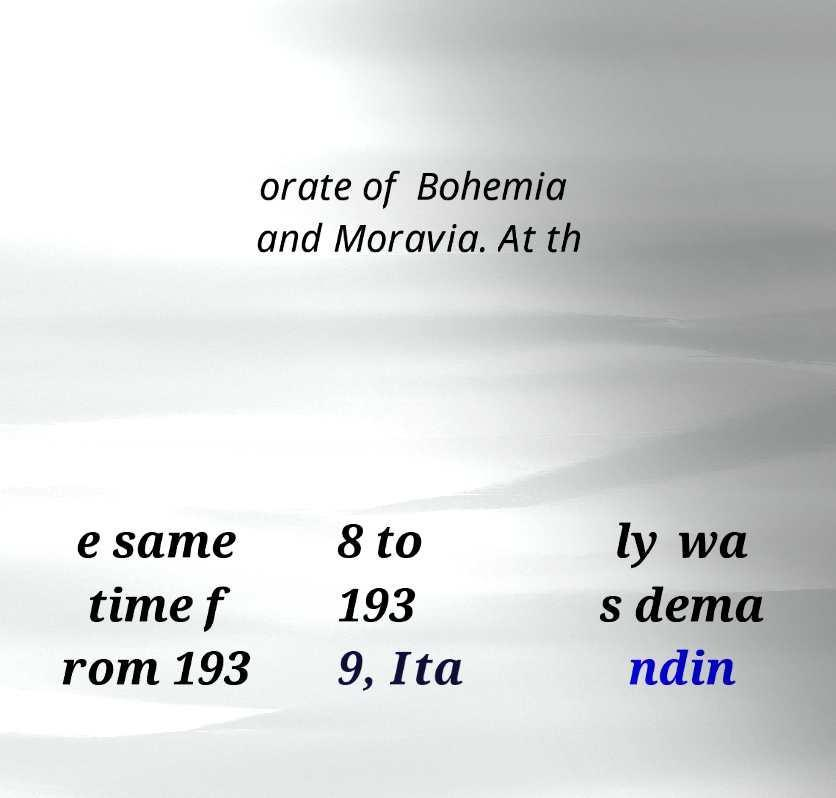Can you accurately transcribe the text from the provided image for me? orate of Bohemia and Moravia. At th e same time f rom 193 8 to 193 9, Ita ly wa s dema ndin 